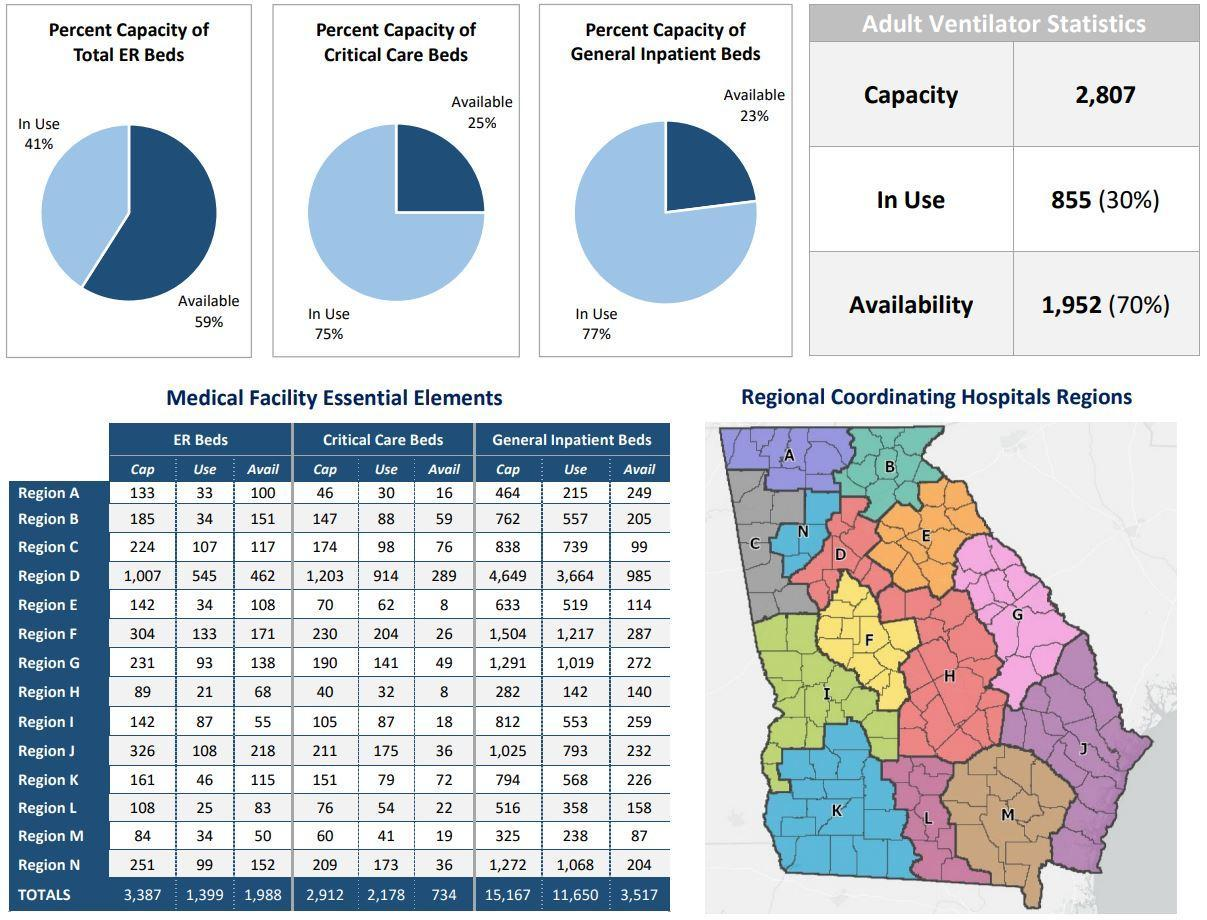How many more ER Beds are available in Region D compared to Region B?
Answer the question with a short phrase. 311 What is the Total number of ER beds in all the regions? 3,387 How many more total ER Beds compared to the total number of Critical care beds are there in region G? 41 How many more number of Critical care beds that are available does Region B have compared to Region J? 23 How many more total number of General Inpatient beds do the Region B have compared to Region A? 298 How many critical care beds are available in Region J? 36 How many more total number of ER Beds do the Region B have compared to Region A? 52 Which color represents the number of available beds in the pie chart, dark blue or green? dark blue How many more total ER Beds compared to the total number of Critical care beds in all regions together? 475 How many critical care beds are available in Region E? 8 How many more number of General Inpatient beds that are available does Region D have compared to Region A? 736 How many more total number of ER Beds do the Region D have compared to Region A? 874 How many more number of General Inpatient beds that are available does Region D have compared to Region J? 753 How many more number of Critical care beds that are available does Region D have compared to Region J? 253 How many more total ER Beds compared to the total number of Critical care beds are there in region F? 74 How many more number of Critical care beds that are available does Region J have compared to Region A? 20 How many more total number of General Inpatient beds do the Region D have compared to Region N? 3,377 How many more ER Beds are available in Region J compared to Region K? 103 What is the Total number of ER beds that are available in all the regions? 1,988 How many more total number of General Inpatient beds do the Region D have compared to Region A? 4,185 